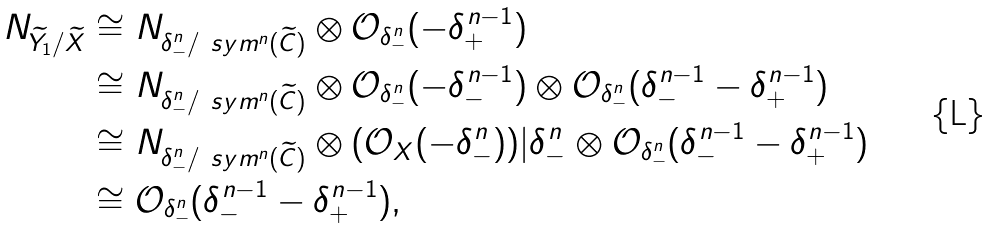<formula> <loc_0><loc_0><loc_500><loc_500>N _ { \widetilde { Y _ { 1 } } / \widetilde { X } } & \cong N _ { \delta _ { - } ^ { n } / \ s y m ^ { n } ( \widetilde { C } ) } \otimes \mathcal { O } _ { \delta _ { - } ^ { n } } ( - \delta _ { + } ^ { n - 1 } ) \\ & \cong N _ { \delta _ { - } ^ { n } / \ s y m ^ { n } ( \widetilde { C } ) } \otimes \mathcal { O } _ { \delta _ { - } ^ { n } } ( - \delta _ { - } ^ { n - 1 } ) \otimes \mathcal { O } _ { \delta _ { - } ^ { n } } ( \delta ^ { n - 1 } _ { - } - \delta ^ { n - 1 } _ { + } ) \\ & \cong N _ { \delta _ { - } ^ { n } / \ s y m ^ { n } ( \widetilde { C } ) } \otimes ( \mathcal { O } _ { X } ( - \delta _ { - } ^ { n } ) ) | { \delta ^ { n } _ { - } } \otimes \mathcal { O } _ { \delta _ { - } ^ { n } } ( \delta ^ { n - 1 } _ { - } - \delta ^ { n - 1 } _ { + } ) \\ & \cong \mathcal { O } _ { \delta _ { - } ^ { n } } ( \delta ^ { n - 1 } _ { - } - \delta ^ { n - 1 } _ { + } ) ,</formula> 